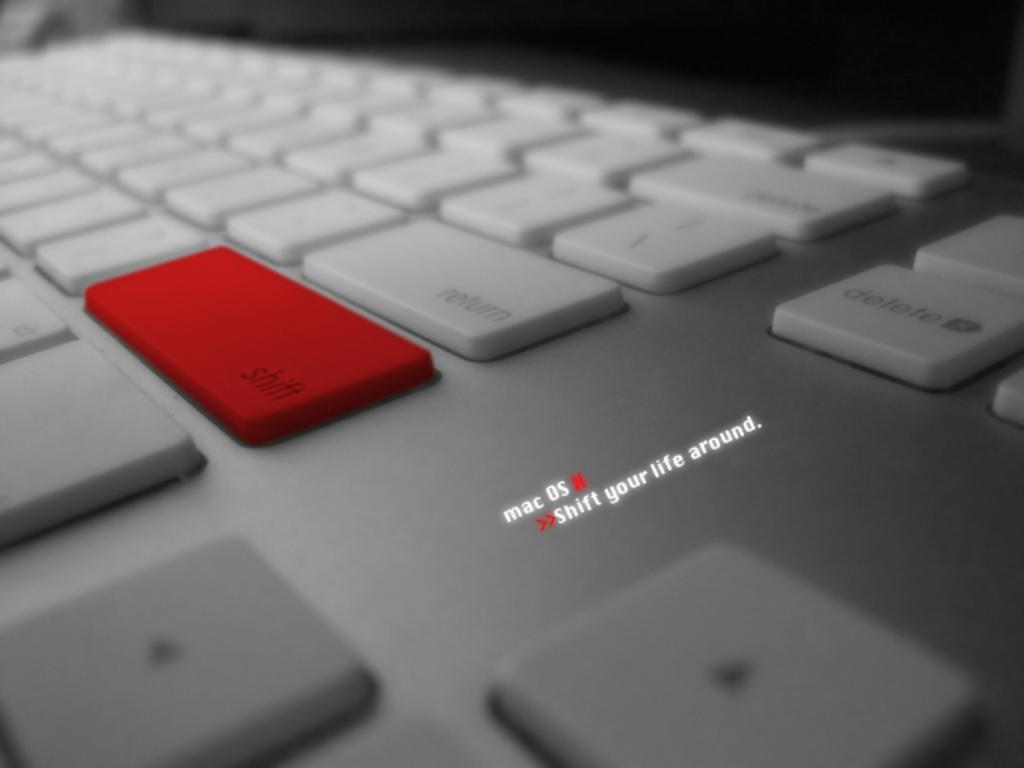Provide a one-sentence caption for the provided image. A keyboard with a red button on the shift key. 